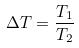<formula> <loc_0><loc_0><loc_500><loc_500>\Delta T = \frac { T _ { 1 } } { T _ { 2 } }</formula> 